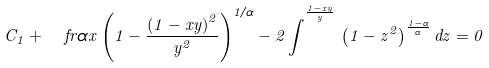Convert formula to latex. <formula><loc_0><loc_0><loc_500><loc_500>C _ { 1 } + \ f r { \alpha } { x } \left ( 1 - { \frac { \left ( 1 - x y \right ) ^ { 2 } } { { y } ^ { 2 } } } \right ) ^ { 1 / \alpha } - 2 \, { \int } ^ { ^ { \frac { 1 - x y } { y } } } \, \left ( 1 - { z } ^ { 2 } \right ) ^ { { \frac { 1 - \alpha } { \alpha } } } { d z } = 0</formula> 